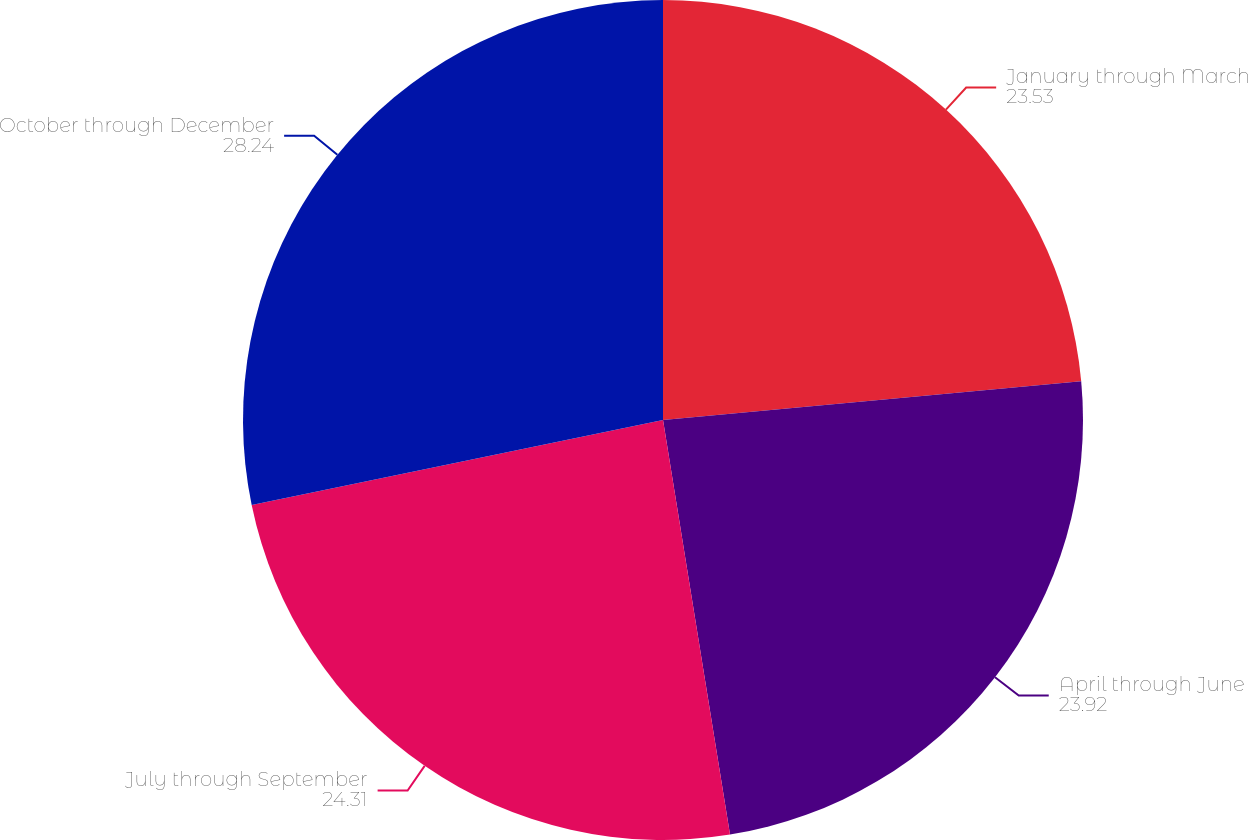Convert chart. <chart><loc_0><loc_0><loc_500><loc_500><pie_chart><fcel>January through March<fcel>April through June<fcel>July through September<fcel>October through December<nl><fcel>23.53%<fcel>23.92%<fcel>24.31%<fcel>28.24%<nl></chart> 